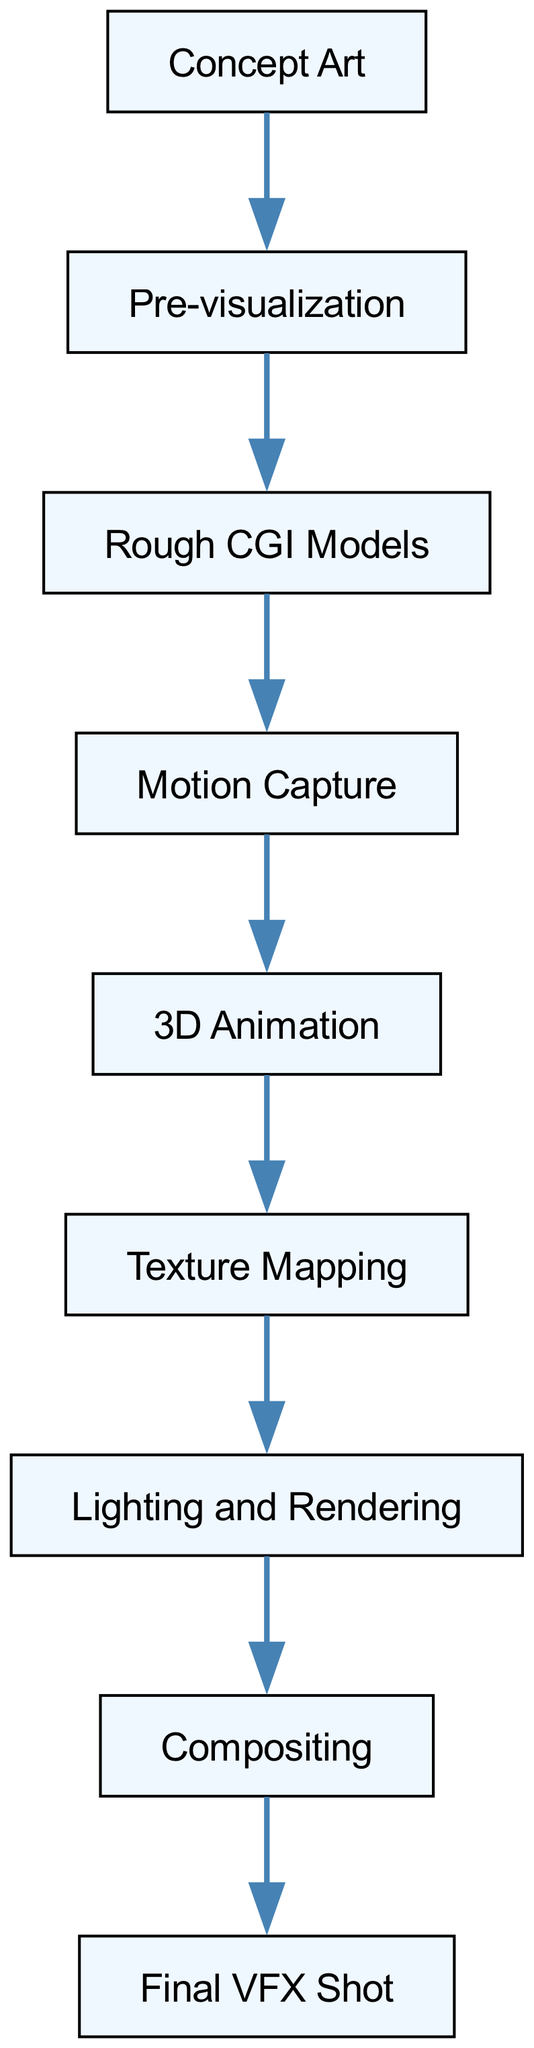What is the first step in the visual effects pipeline? The visual effects pipeline begins with "Concept Art," which is the foundational step where ideas are illustrated.
Answer: Concept Art How many nodes are there in the diagram? There are nine nodes in the diagram, representing each step in the visual effects pipeline from Concept Art to Final VFX Shot.
Answer: Nine What step comes after Lighting and Rendering? The step that follows Lighting and Rendering is "Compositing," where all elements are combined to create the final visual output.
Answer: Compositing What element is consumed by 3D Animation? "Motion Capture" is consumed by 3D Animation, showing that it relies on captured motion data for the animation process.
Answer: Motion Capture Which element directly leads to the Final VFX Shot? The element that directly leads to the Final VFX Shot is "Compositing," as it is the last step before final output is achieved.
Answer: Compositing How many steps are directly connected to Rough CGI Models? There is one step directly connected to Rough CGI Models, which is "Motion Capture." This means that Motion Capture relies on Rough CGI Models to proceed.
Answer: One What role does Texture Mapping play in the pipeline? Texture Mapping is essential in the pipeline as it provides the surfaces and details to 3D animation, enhancing realism before rendering.
Answer: Provides surfaces What is the relationship between Pre-visualization and Rough CGI Models? Pre-visualization is a prerequisite for Rough CGI Models; the latter uses the planning and guidance provided by Pre-visualization to create models.
Answer: Prerequisite Which step serves as the foundation for subsequent steps in the pipeline? "Concept Art" serves as the foundation for all subsequent steps in the visual effects pipeline as it provides the initial concepts.
Answer: Concept Art 